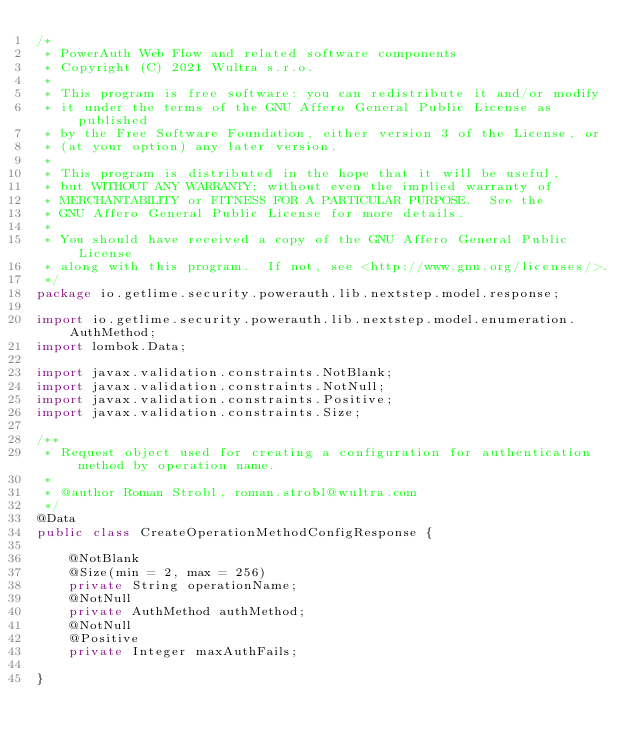<code> <loc_0><loc_0><loc_500><loc_500><_Java_>/*
 * PowerAuth Web Flow and related software components
 * Copyright (C) 2021 Wultra s.r.o.
 *
 * This program is free software: you can redistribute it and/or modify
 * it under the terms of the GNU Affero General Public License as published
 * by the Free Software Foundation, either version 3 of the License, or
 * (at your option) any later version.
 *
 * This program is distributed in the hope that it will be useful,
 * but WITHOUT ANY WARRANTY; without even the implied warranty of
 * MERCHANTABILITY or FITNESS FOR A PARTICULAR PURPOSE.  See the
 * GNU Affero General Public License for more details.
 *
 * You should have received a copy of the GNU Affero General Public License
 * along with this program.  If not, see <http://www.gnu.org/licenses/>.
 */
package io.getlime.security.powerauth.lib.nextstep.model.response;

import io.getlime.security.powerauth.lib.nextstep.model.enumeration.AuthMethod;
import lombok.Data;

import javax.validation.constraints.NotBlank;
import javax.validation.constraints.NotNull;
import javax.validation.constraints.Positive;
import javax.validation.constraints.Size;

/**
 * Request object used for creating a configuration for authentication method by operation name.
 *
 * @author Roman Strobl, roman.strobl@wultra.com
 */
@Data
public class CreateOperationMethodConfigResponse {

    @NotBlank
    @Size(min = 2, max = 256)
    private String operationName;
    @NotNull
    private AuthMethod authMethod;
    @NotNull
    @Positive
    private Integer maxAuthFails;

}
</code> 